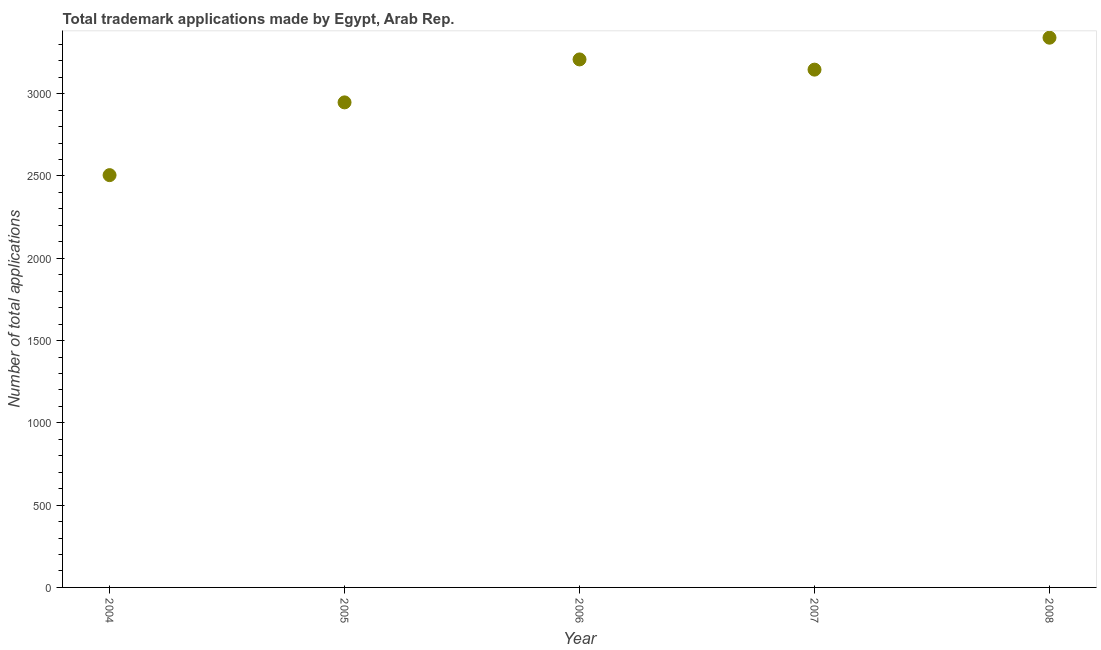What is the number of trademark applications in 2004?
Your answer should be very brief. 2505. Across all years, what is the maximum number of trademark applications?
Give a very brief answer. 3340. Across all years, what is the minimum number of trademark applications?
Give a very brief answer. 2505. In which year was the number of trademark applications maximum?
Make the answer very short. 2008. In which year was the number of trademark applications minimum?
Provide a short and direct response. 2004. What is the sum of the number of trademark applications?
Your answer should be very brief. 1.51e+04. What is the difference between the number of trademark applications in 2005 and 2006?
Provide a short and direct response. -261. What is the average number of trademark applications per year?
Make the answer very short. 3029.2. What is the median number of trademark applications?
Keep it short and to the point. 3146. Do a majority of the years between 2007 and 2008 (inclusive) have number of trademark applications greater than 300 ?
Give a very brief answer. Yes. What is the ratio of the number of trademark applications in 2004 to that in 2007?
Offer a terse response. 0.8. What is the difference between the highest and the second highest number of trademark applications?
Provide a succinct answer. 132. Is the sum of the number of trademark applications in 2004 and 2007 greater than the maximum number of trademark applications across all years?
Make the answer very short. Yes. What is the difference between the highest and the lowest number of trademark applications?
Offer a very short reply. 835. In how many years, is the number of trademark applications greater than the average number of trademark applications taken over all years?
Give a very brief answer. 3. How many years are there in the graph?
Offer a terse response. 5. Does the graph contain grids?
Offer a very short reply. No. What is the title of the graph?
Ensure brevity in your answer.  Total trademark applications made by Egypt, Arab Rep. What is the label or title of the X-axis?
Your answer should be compact. Year. What is the label or title of the Y-axis?
Give a very brief answer. Number of total applications. What is the Number of total applications in 2004?
Provide a succinct answer. 2505. What is the Number of total applications in 2005?
Ensure brevity in your answer.  2947. What is the Number of total applications in 2006?
Provide a succinct answer. 3208. What is the Number of total applications in 2007?
Your response must be concise. 3146. What is the Number of total applications in 2008?
Your response must be concise. 3340. What is the difference between the Number of total applications in 2004 and 2005?
Your answer should be compact. -442. What is the difference between the Number of total applications in 2004 and 2006?
Provide a short and direct response. -703. What is the difference between the Number of total applications in 2004 and 2007?
Your response must be concise. -641. What is the difference between the Number of total applications in 2004 and 2008?
Keep it short and to the point. -835. What is the difference between the Number of total applications in 2005 and 2006?
Your answer should be compact. -261. What is the difference between the Number of total applications in 2005 and 2007?
Offer a terse response. -199. What is the difference between the Number of total applications in 2005 and 2008?
Offer a terse response. -393. What is the difference between the Number of total applications in 2006 and 2008?
Offer a very short reply. -132. What is the difference between the Number of total applications in 2007 and 2008?
Your answer should be compact. -194. What is the ratio of the Number of total applications in 2004 to that in 2006?
Your answer should be very brief. 0.78. What is the ratio of the Number of total applications in 2004 to that in 2007?
Give a very brief answer. 0.8. What is the ratio of the Number of total applications in 2004 to that in 2008?
Keep it short and to the point. 0.75. What is the ratio of the Number of total applications in 2005 to that in 2006?
Your response must be concise. 0.92. What is the ratio of the Number of total applications in 2005 to that in 2007?
Ensure brevity in your answer.  0.94. What is the ratio of the Number of total applications in 2005 to that in 2008?
Make the answer very short. 0.88. What is the ratio of the Number of total applications in 2006 to that in 2007?
Provide a succinct answer. 1.02. What is the ratio of the Number of total applications in 2007 to that in 2008?
Provide a short and direct response. 0.94. 